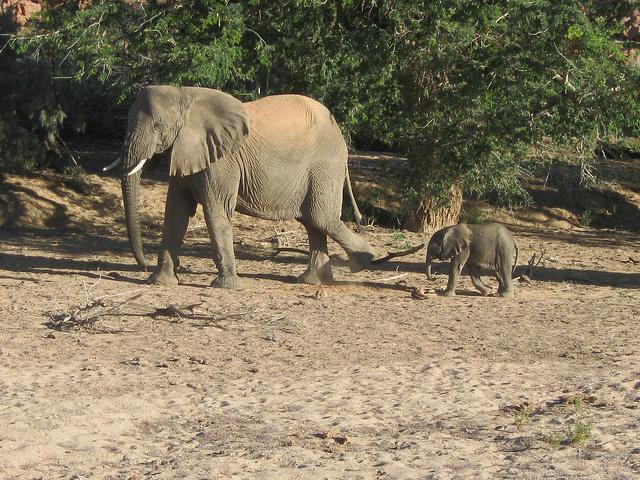How many elephants are there?
Give a very brief answer. 2. 